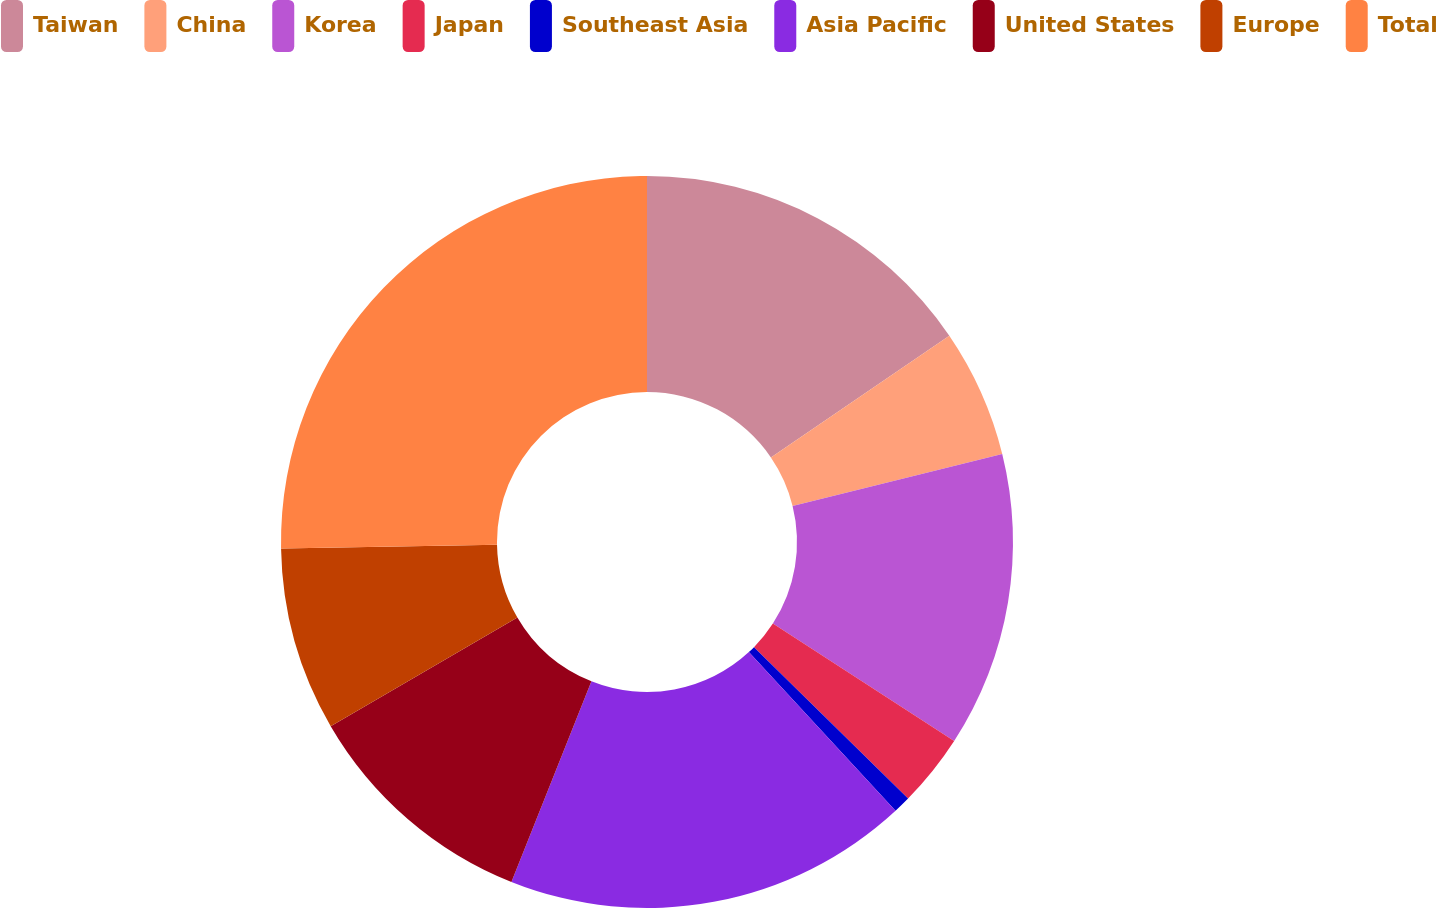Convert chart. <chart><loc_0><loc_0><loc_500><loc_500><pie_chart><fcel>Taiwan<fcel>China<fcel>Korea<fcel>Japan<fcel>Southeast Asia<fcel>Asia Pacific<fcel>United States<fcel>Europe<fcel>Total<nl><fcel>15.47%<fcel>5.66%<fcel>13.02%<fcel>3.21%<fcel>0.76%<fcel>17.92%<fcel>10.57%<fcel>8.11%<fcel>25.28%<nl></chart> 